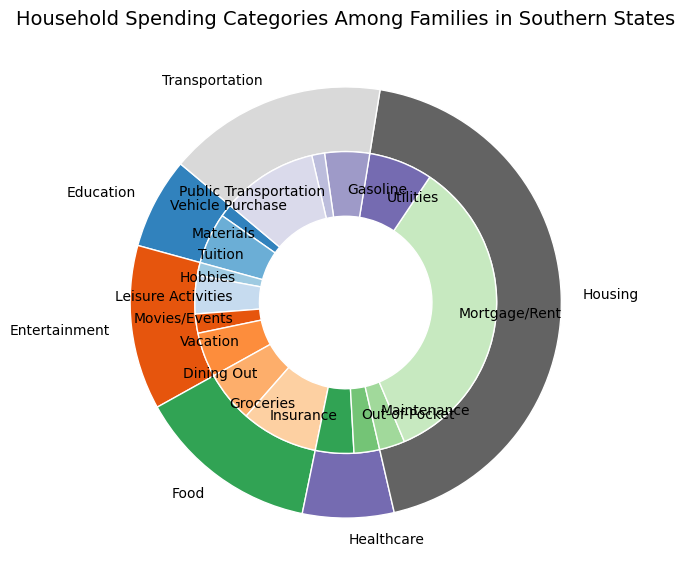What is the largest spending category? The largest spending category can be determined by looking at the largest segment in the outer pie chart. The segment labeled "Housing" is the largest.
Answer: Housing How much is spent on Vacation compared to Movies/Events? To find the amount spent on Vacation compared to Movies/Events, look at the inner pie chart and compare the sections labeled "Vacation" and "Movies/Events". Vacation is $3500 and Movies/Events is $1500.
Answer: Vacation is $2000 more Which category has the smallest spending amount? The smallest spending category can be identified by looking at the smallest segment in the outer pie chart, which is "Education" at $5000.
Answer: Education Sum the spending on Mortgage/Rent and Groceries. Add the amounts from the inner pie chart segments for "Mortgage/Rent" ($25000) and "Groceries" ($6000).
Answer: $31000 Which subcategory in Transportation has the highest spending? The subcategory with the highest spending in Transportation is found by looking at the inner pie chart sections under Transportation. "Vehicle Purchase" has the highest amount at $7500.
Answer: Vehicle Purchase What is the total spending on Healthcare and Education combined? Add the total amounts from the outer pie chart segments for Healthcare ($5000) and Education ($5000).
Answer: $10000 Is more money spent on Dining Out or Hobbies? Compare the sections in the inner pie chart labeled "Dining Out" ($4000) and "Hobbies" ($1000).
Answer: Dining Out How does the spending on Insurance compare to Out-of-Pocket expenses? Look at the inner pie chart sections for Healthcare. Insurance is $3000 and Out-of-Pocket is $2000.
Answer: Insurance is $1000 more Which category has the most even distribution of subcategories? The distribution can be analyzed by observing the relative sizes of the subcategories within each category. "Food" (with Groceries and Dining Out) has relatively similar segment sizes compared to other categories.
Answer: Food 